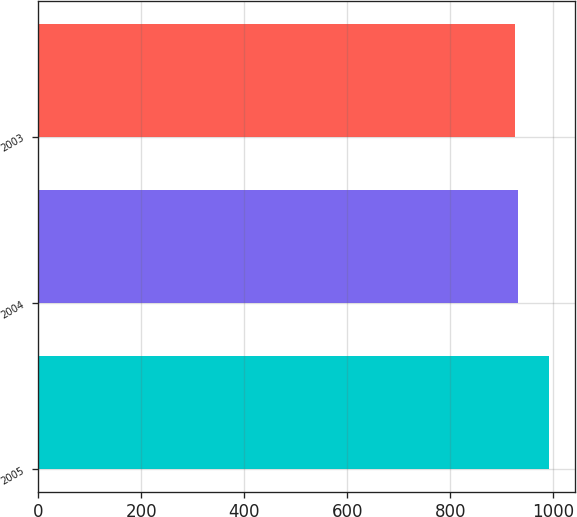<chart> <loc_0><loc_0><loc_500><loc_500><bar_chart><fcel>2005<fcel>2004<fcel>2003<nl><fcel>992.1<fcel>932.34<fcel>925.7<nl></chart> 